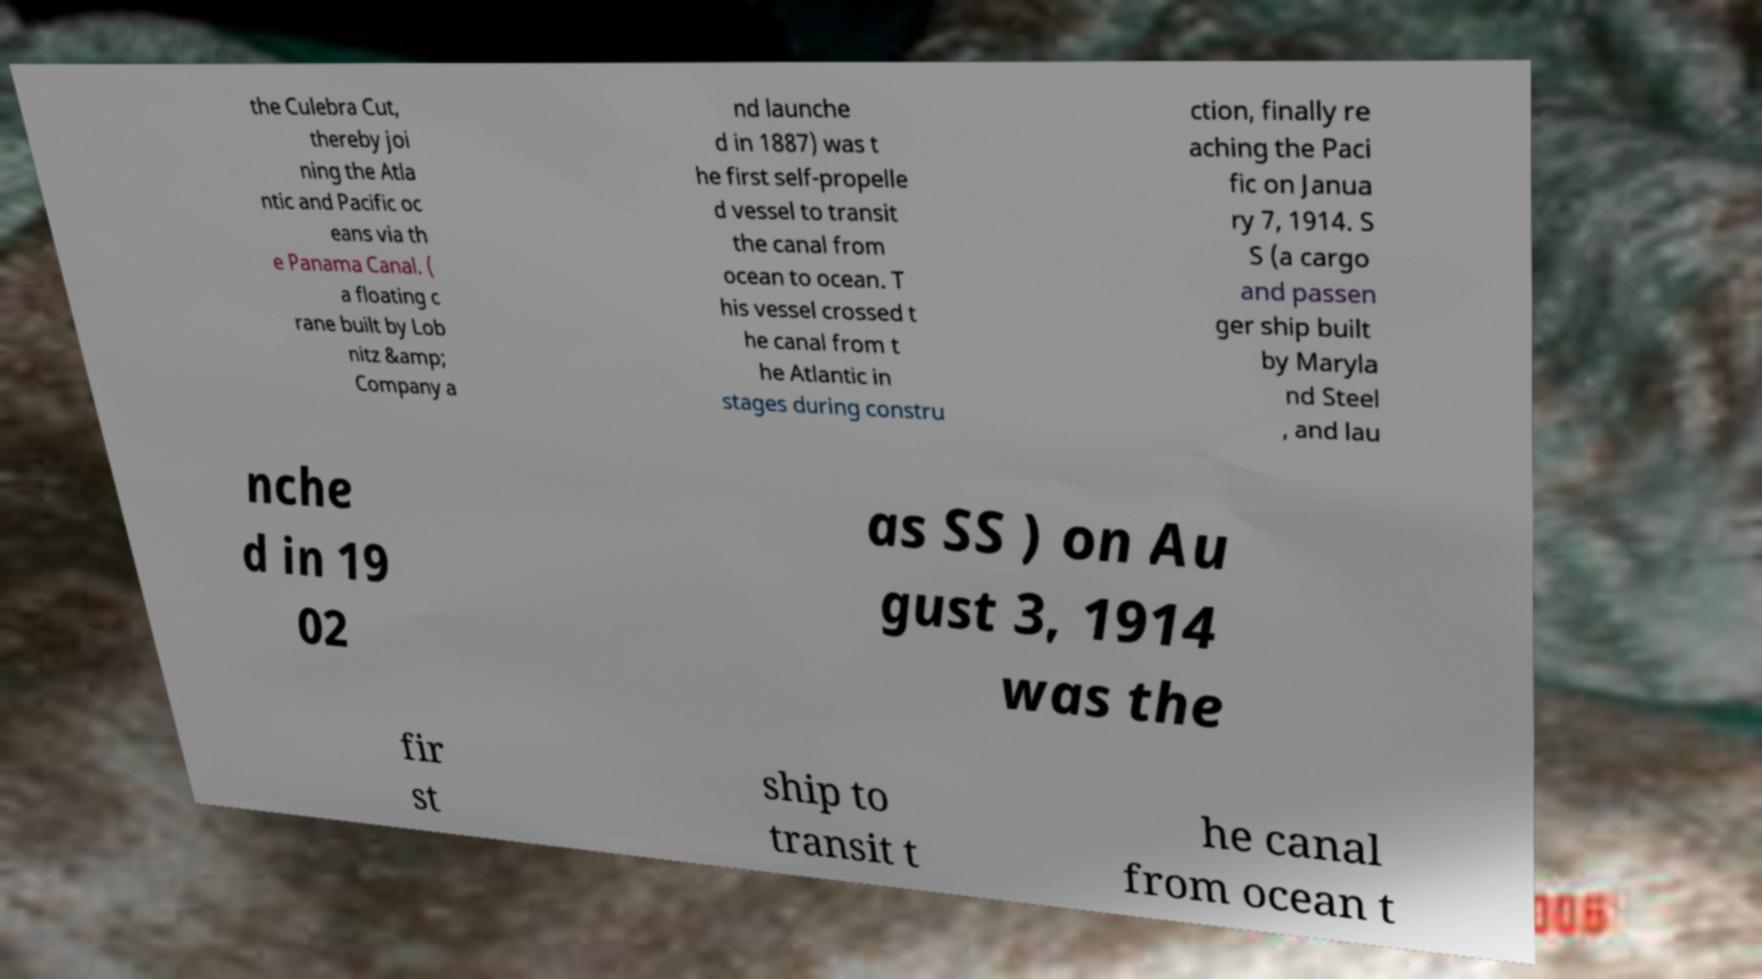Please identify and transcribe the text found in this image. the Culebra Cut, thereby joi ning the Atla ntic and Pacific oc eans via th e Panama Canal. ( a floating c rane built by Lob nitz &amp; Company a nd launche d in 1887) was t he first self-propelle d vessel to transit the canal from ocean to ocean. T his vessel crossed t he canal from t he Atlantic in stages during constru ction, finally re aching the Paci fic on Janua ry 7, 1914. S S (a cargo and passen ger ship built by Maryla nd Steel , and lau nche d in 19 02 as SS ) on Au gust 3, 1914 was the fir st ship to transit t he canal from ocean t 